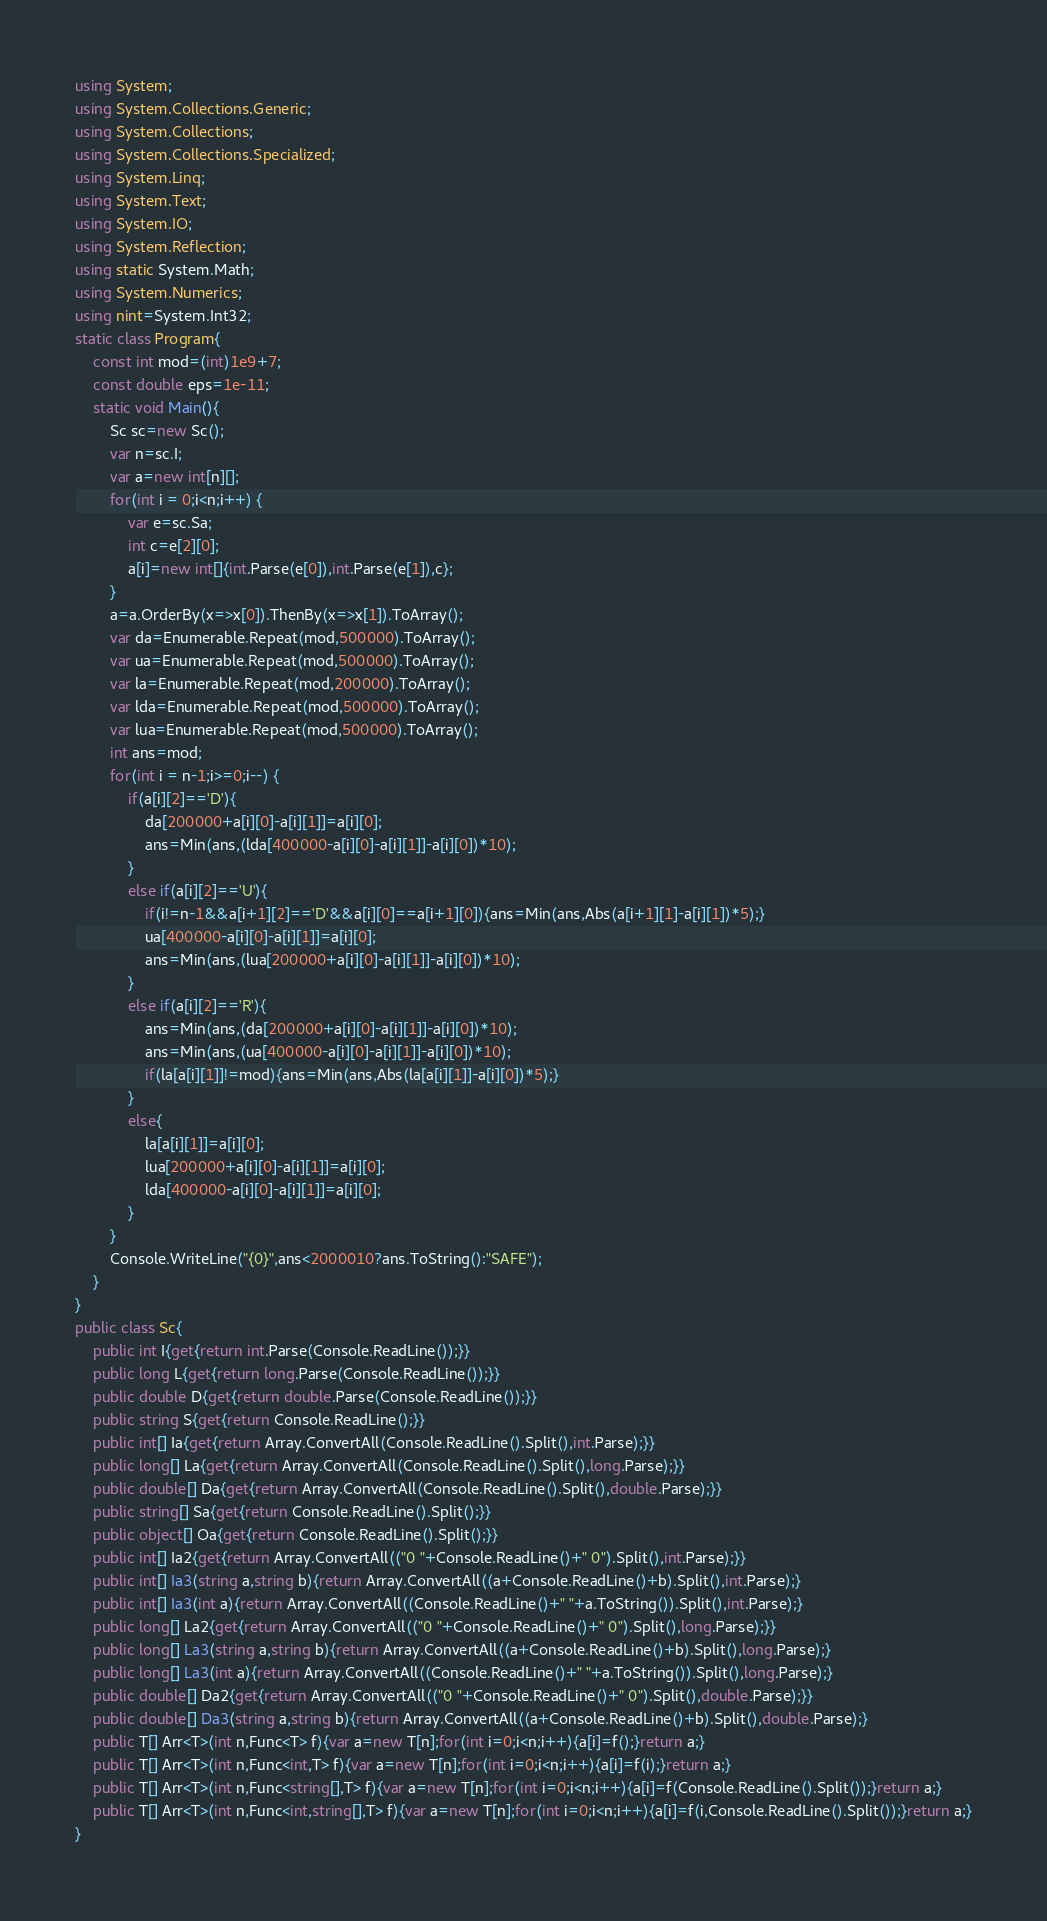Convert code to text. <code><loc_0><loc_0><loc_500><loc_500><_C#_>using System;
using System.Collections.Generic;
using System.Collections;
using System.Collections.Specialized;
using System.Linq;
using System.Text;
using System.IO;
using System.Reflection;
using static System.Math;
using System.Numerics;
using nint=System.Int32;
static class Program{
	const int mod=(int)1e9+7;
	const double eps=1e-11;
	static void Main(){
		Sc sc=new Sc();
		var n=sc.I;
		var a=new int[n][];
		for(int i = 0;i<n;i++) {
			var e=sc.Sa;
			int c=e[2][0];
			a[i]=new int[]{int.Parse(e[0]),int.Parse(e[1]),c};
		}
		a=a.OrderBy(x=>x[0]).ThenBy(x=>x[1]).ToArray();
		var da=Enumerable.Repeat(mod,500000).ToArray();
		var ua=Enumerable.Repeat(mod,500000).ToArray();
		var la=Enumerable.Repeat(mod,200000).ToArray();
		var lda=Enumerable.Repeat(mod,500000).ToArray();
		var lua=Enumerable.Repeat(mod,500000).ToArray();
		int ans=mod;
		for(int i = n-1;i>=0;i--) {
			if(a[i][2]=='D'){
				da[200000+a[i][0]-a[i][1]]=a[i][0];
				ans=Min(ans,(lda[400000-a[i][0]-a[i][1]]-a[i][0])*10);
			}
			else if(a[i][2]=='U'){
				if(i!=n-1&&a[i+1][2]=='D'&&a[i][0]==a[i+1][0]){ans=Min(ans,Abs(a[i+1][1]-a[i][1])*5);}
				ua[400000-a[i][0]-a[i][1]]=a[i][0];
				ans=Min(ans,(lua[200000+a[i][0]-a[i][1]]-a[i][0])*10);
			}
			else if(a[i][2]=='R'){
				ans=Min(ans,(da[200000+a[i][0]-a[i][1]]-a[i][0])*10);
				ans=Min(ans,(ua[400000-a[i][0]-a[i][1]]-a[i][0])*10);
				if(la[a[i][1]]!=mod){ans=Min(ans,Abs(la[a[i][1]]-a[i][0])*5);}
			}
			else{
				la[a[i][1]]=a[i][0];
				lua[200000+a[i][0]-a[i][1]]=a[i][0];
				lda[400000-a[i][0]-a[i][1]]=a[i][0];
			}
		}
		Console.WriteLine("{0}",ans<2000010?ans.ToString():"SAFE");
	}
}
public class Sc{
	public int I{get{return int.Parse(Console.ReadLine());}}
	public long L{get{return long.Parse(Console.ReadLine());}}
	public double D{get{return double.Parse(Console.ReadLine());}}
	public string S{get{return Console.ReadLine();}}
	public int[] Ia{get{return Array.ConvertAll(Console.ReadLine().Split(),int.Parse);}}
	public long[] La{get{return Array.ConvertAll(Console.ReadLine().Split(),long.Parse);}}
	public double[] Da{get{return Array.ConvertAll(Console.ReadLine().Split(),double.Parse);}}
	public string[] Sa{get{return Console.ReadLine().Split();}}
	public object[] Oa{get{return Console.ReadLine().Split();}}
	public int[] Ia2{get{return Array.ConvertAll(("0 "+Console.ReadLine()+" 0").Split(),int.Parse);}}
	public int[] Ia3(string a,string b){return Array.ConvertAll((a+Console.ReadLine()+b).Split(),int.Parse);}
	public int[] Ia3(int a){return Array.ConvertAll((Console.ReadLine()+" "+a.ToString()).Split(),int.Parse);}
	public long[] La2{get{return Array.ConvertAll(("0 "+Console.ReadLine()+" 0").Split(),long.Parse);}}
	public long[] La3(string a,string b){return Array.ConvertAll((a+Console.ReadLine()+b).Split(),long.Parse);}
	public long[] La3(int a){return Array.ConvertAll((Console.ReadLine()+" "+a.ToString()).Split(),long.Parse);}
	public double[] Da2{get{return Array.ConvertAll(("0 "+Console.ReadLine()+" 0").Split(),double.Parse);}}
	public double[] Da3(string a,string b){return Array.ConvertAll((a+Console.ReadLine()+b).Split(),double.Parse);}
	public T[] Arr<T>(int n,Func<T> f){var a=new T[n];for(int i=0;i<n;i++){a[i]=f();}return a;}
	public T[] Arr<T>(int n,Func<int,T> f){var a=new T[n];for(int i=0;i<n;i++){a[i]=f(i);}return a;}
	public T[] Arr<T>(int n,Func<string[],T> f){var a=new T[n];for(int i=0;i<n;i++){a[i]=f(Console.ReadLine().Split());}return a;}
	public T[] Arr<T>(int n,Func<int,string[],T> f){var a=new T[n];for(int i=0;i<n;i++){a[i]=f(i,Console.ReadLine().Split());}return a;}
}</code> 